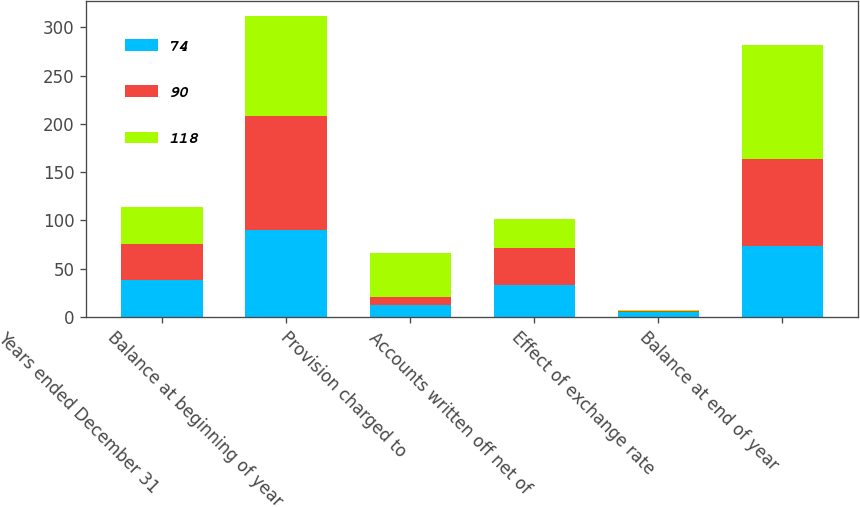Convert chart to OTSL. <chart><loc_0><loc_0><loc_500><loc_500><stacked_bar_chart><ecel><fcel>Years ended December 31<fcel>Balance at beginning of year<fcel>Provision charged to<fcel>Accounts written off net of<fcel>Effect of exchange rate<fcel>Balance at end of year<nl><fcel>74<fcel>38<fcel>90<fcel>12<fcel>33<fcel>5<fcel>74<nl><fcel>90<fcel>38<fcel>118<fcel>9<fcel>38<fcel>1<fcel>90<nl><fcel>118<fcel>38<fcel>104<fcel>45<fcel>30<fcel>1<fcel>118<nl></chart> 